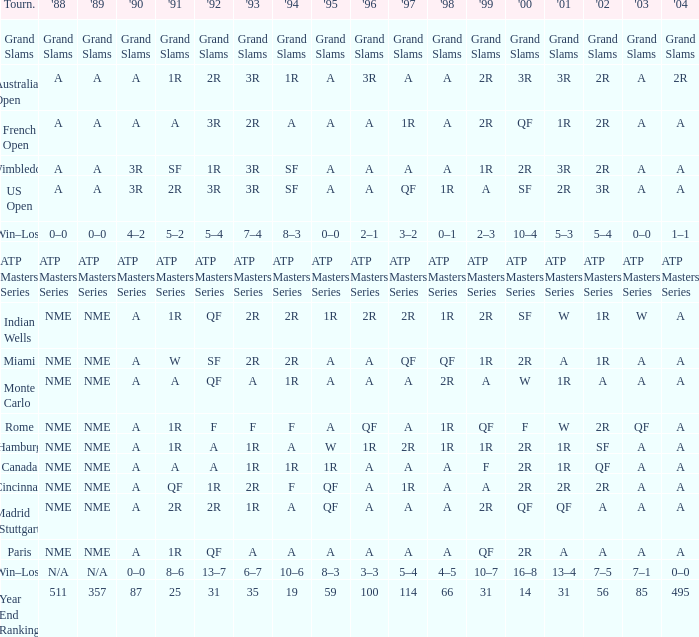Could you help me parse every detail presented in this table? {'header': ['Tourn.', "'88", "'89", "'90", "'91", "'92", "'93", "'94", "'95", "'96", "'97", "'98", "'99", "'00", "'01", "'02", "'03", "'04"], 'rows': [['Grand Slams', 'Grand Slams', 'Grand Slams', 'Grand Slams', 'Grand Slams', 'Grand Slams', 'Grand Slams', 'Grand Slams', 'Grand Slams', 'Grand Slams', 'Grand Slams', 'Grand Slams', 'Grand Slams', 'Grand Slams', 'Grand Slams', 'Grand Slams', 'Grand Slams', 'Grand Slams'], ['Australian Open', 'A', 'A', 'A', '1R', '2R', '3R', '1R', 'A', '3R', 'A', 'A', '2R', '3R', '3R', '2R', 'A', '2R'], ['French Open', 'A', 'A', 'A', 'A', '3R', '2R', 'A', 'A', 'A', '1R', 'A', '2R', 'QF', '1R', '2R', 'A', 'A'], ['Wimbledon', 'A', 'A', '3R', 'SF', '1R', '3R', 'SF', 'A', 'A', 'A', 'A', '1R', '2R', '3R', '2R', 'A', 'A'], ['US Open', 'A', 'A', '3R', '2R', '3R', '3R', 'SF', 'A', 'A', 'QF', '1R', 'A', 'SF', '2R', '3R', 'A', 'A'], ['Win–Loss', '0–0', '0–0', '4–2', '5–2', '5–4', '7–4', '8–3', '0–0', '2–1', '3–2', '0–1', '2–3', '10–4', '5–3', '5–4', '0–0', '1–1'], ['ATP Masters Series', 'ATP Masters Series', 'ATP Masters Series', 'ATP Masters Series', 'ATP Masters Series', 'ATP Masters Series', 'ATP Masters Series', 'ATP Masters Series', 'ATP Masters Series', 'ATP Masters Series', 'ATP Masters Series', 'ATP Masters Series', 'ATP Masters Series', 'ATP Masters Series', 'ATP Masters Series', 'ATP Masters Series', 'ATP Masters Series', 'ATP Masters Series'], ['Indian Wells', 'NME', 'NME', 'A', '1R', 'QF', '2R', '2R', '1R', '2R', '2R', '1R', '2R', 'SF', 'W', '1R', 'W', 'A'], ['Miami', 'NME', 'NME', 'A', 'W', 'SF', '2R', '2R', 'A', 'A', 'QF', 'QF', '1R', '2R', 'A', '1R', 'A', 'A'], ['Monte Carlo', 'NME', 'NME', 'A', 'A', 'QF', 'A', '1R', 'A', 'A', 'A', '2R', 'A', 'W', '1R', 'A', 'A', 'A'], ['Rome', 'NME', 'NME', 'A', '1R', 'F', 'F', 'F', 'A', 'QF', 'A', '1R', 'QF', 'F', 'W', '2R', 'QF', 'A'], ['Hamburg', 'NME', 'NME', 'A', '1R', 'A', '1R', 'A', 'W', '1R', '2R', '1R', '1R', '2R', '1R', 'SF', 'A', 'A'], ['Canada', 'NME', 'NME', 'A', 'A', 'A', '1R', '1R', '1R', 'A', 'A', 'A', 'F', '2R', '1R', 'QF', 'A', 'A'], ['Cincinnati', 'NME', 'NME', 'A', 'QF', '1R', '2R', 'F', 'QF', 'A', '1R', 'A', 'A', '2R', '2R', '2R', 'A', 'A'], ['Madrid (Stuttgart)', 'NME', 'NME', 'A', '2R', '2R', '1R', 'A', 'QF', 'A', 'A', 'A', '2R', 'QF', 'QF', 'A', 'A', 'A'], ['Paris', 'NME', 'NME', 'A', '1R', 'QF', 'A', 'A', 'A', 'A', 'A', 'A', 'QF', '2R', 'A', 'A', 'A', 'A'], ['Win–Loss', 'N/A', 'N/A', '0–0', '8–6', '13–7', '6–7', '10–6', '8–3', '3–3', '5–4', '4–5', '10–7', '16–8', '13–4', '7–5', '7–1', '0–0'], ['Year End Ranking', '511', '357', '87', '25', '31', '35', '19', '59', '100', '114', '66', '31', '14', '31', '56', '85', '495']]} What shows for 202 when the 1994 is A, the 1989 is NME, and the 199 is 2R? A. 